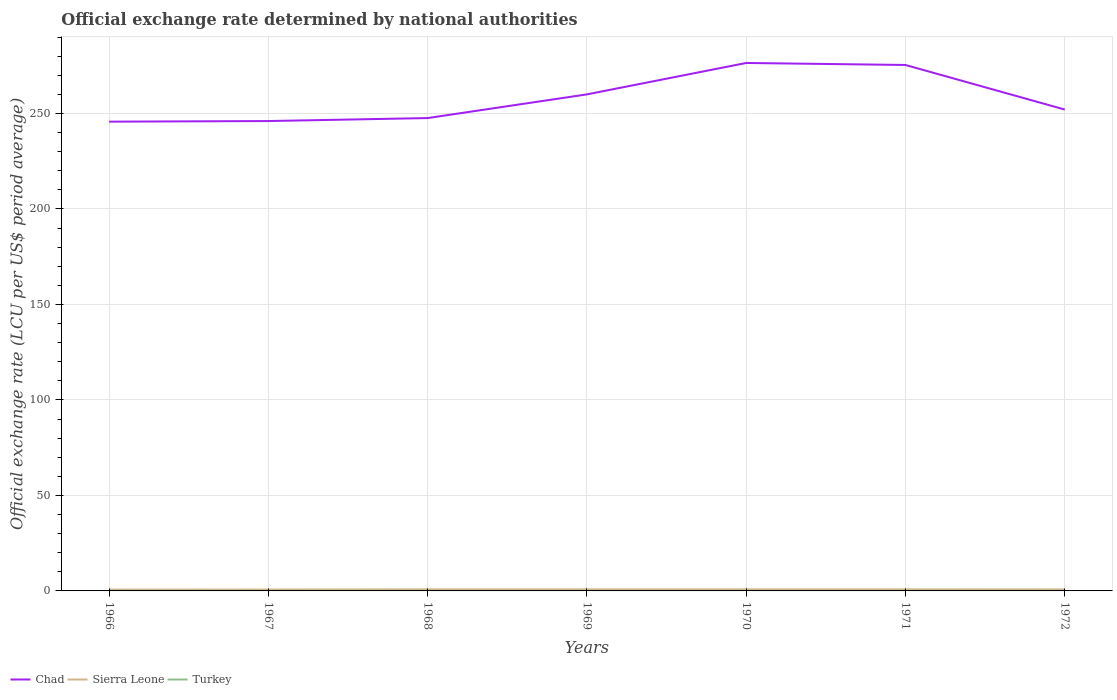Does the line corresponding to Sierra Leone intersect with the line corresponding to Chad?
Your response must be concise. No. Across all years, what is the maximum official exchange rate in Turkey?
Offer a very short reply. 9.039999999e-6. In which year was the official exchange rate in Sierra Leone maximum?
Keep it short and to the point. 1966. What is the total official exchange rate in Chad in the graph?
Offer a very short reply. -6.35. What is the difference between the highest and the second highest official exchange rate in Turkey?
Ensure brevity in your answer.  5.8266666680833e-6. How many lines are there?
Your answer should be very brief. 3. Does the graph contain any zero values?
Offer a terse response. No. Does the graph contain grids?
Provide a short and direct response. Yes. Where does the legend appear in the graph?
Your answer should be compact. Bottom left. How many legend labels are there?
Give a very brief answer. 3. How are the legend labels stacked?
Ensure brevity in your answer.  Horizontal. What is the title of the graph?
Make the answer very short. Official exchange rate determined by national authorities. Does "Hungary" appear as one of the legend labels in the graph?
Ensure brevity in your answer.  No. What is the label or title of the X-axis?
Your answer should be very brief. Years. What is the label or title of the Y-axis?
Make the answer very short. Official exchange rate (LCU per US$ period average). What is the Official exchange rate (LCU per US$ period average) of Chad in 1966?
Offer a terse response. 245.68. What is the Official exchange rate (LCU per US$ period average) of Sierra Leone in 1966?
Ensure brevity in your answer.  0.71. What is the Official exchange rate (LCU per US$ period average) in Turkey in 1966?
Make the answer very short. 9.039999999e-6. What is the Official exchange rate (LCU per US$ period average) in Chad in 1967?
Your response must be concise. 246. What is the Official exchange rate (LCU per US$ period average) in Sierra Leone in 1967?
Your answer should be very brief. 0.72. What is the Official exchange rate (LCU per US$ period average) of Turkey in 1967?
Provide a short and direct response. 9.039999999e-6. What is the Official exchange rate (LCU per US$ period average) of Chad in 1968?
Your answer should be compact. 247.56. What is the Official exchange rate (LCU per US$ period average) in Sierra Leone in 1968?
Your answer should be compact. 0.83. What is the Official exchange rate (LCU per US$ period average) in Turkey in 1968?
Give a very brief answer. 9.039999999e-6. What is the Official exchange rate (LCU per US$ period average) in Chad in 1969?
Your answer should be very brief. 259.96. What is the Official exchange rate (LCU per US$ period average) in Sierra Leone in 1969?
Ensure brevity in your answer.  0.83. What is the Official exchange rate (LCU per US$ period average) in Turkey in 1969?
Your answer should be very brief. 9.039999999e-6. What is the Official exchange rate (LCU per US$ period average) in Chad in 1970?
Offer a terse response. 276.4. What is the Official exchange rate (LCU per US$ period average) of Sierra Leone in 1970?
Keep it short and to the point. 0.83. What is the Official exchange rate (LCU per US$ period average) of Turkey in 1970?
Your answer should be very brief. 1.1328499999e-5. What is the Official exchange rate (LCU per US$ period average) in Chad in 1971?
Make the answer very short. 275.36. What is the Official exchange rate (LCU per US$ period average) of Sierra Leone in 1971?
Offer a very short reply. 0.83. What is the Official exchange rate (LCU per US$ period average) in Turkey in 1971?
Your response must be concise. 1.48666666670833e-5. What is the Official exchange rate (LCU per US$ period average) of Chad in 1972?
Give a very brief answer. 252.03. What is the Official exchange rate (LCU per US$ period average) in Sierra Leone in 1972?
Keep it short and to the point. 0.8. What is the Official exchange rate (LCU per US$ period average) of Turkey in 1972?
Your answer should be very brief. 1.415e-5. Across all years, what is the maximum Official exchange rate (LCU per US$ period average) of Chad?
Offer a terse response. 276.4. Across all years, what is the maximum Official exchange rate (LCU per US$ period average) of Sierra Leone?
Keep it short and to the point. 0.83. Across all years, what is the maximum Official exchange rate (LCU per US$ period average) in Turkey?
Your answer should be very brief. 1.48666666670833e-5. Across all years, what is the minimum Official exchange rate (LCU per US$ period average) of Chad?
Offer a terse response. 245.68. Across all years, what is the minimum Official exchange rate (LCU per US$ period average) in Sierra Leone?
Offer a very short reply. 0.71. Across all years, what is the minimum Official exchange rate (LCU per US$ period average) in Turkey?
Offer a terse response. 9.039999999e-6. What is the total Official exchange rate (LCU per US$ period average) of Chad in the graph?
Provide a succinct answer. 1802.99. What is the total Official exchange rate (LCU per US$ period average) in Sierra Leone in the graph?
Your answer should be very brief. 5.57. What is the difference between the Official exchange rate (LCU per US$ period average) in Chad in 1966 and that in 1967?
Ensure brevity in your answer.  -0.32. What is the difference between the Official exchange rate (LCU per US$ period average) in Sierra Leone in 1966 and that in 1967?
Your response must be concise. -0.01. What is the difference between the Official exchange rate (LCU per US$ period average) of Turkey in 1966 and that in 1967?
Your response must be concise. 0. What is the difference between the Official exchange rate (LCU per US$ period average) of Chad in 1966 and that in 1968?
Make the answer very short. -1.89. What is the difference between the Official exchange rate (LCU per US$ period average) in Sierra Leone in 1966 and that in 1968?
Your answer should be very brief. -0.12. What is the difference between the Official exchange rate (LCU per US$ period average) in Turkey in 1966 and that in 1968?
Your response must be concise. 0. What is the difference between the Official exchange rate (LCU per US$ period average) of Chad in 1966 and that in 1969?
Ensure brevity in your answer.  -14.28. What is the difference between the Official exchange rate (LCU per US$ period average) in Sierra Leone in 1966 and that in 1969?
Make the answer very short. -0.12. What is the difference between the Official exchange rate (LCU per US$ period average) in Chad in 1966 and that in 1970?
Give a very brief answer. -30.72. What is the difference between the Official exchange rate (LCU per US$ period average) of Sierra Leone in 1966 and that in 1970?
Your answer should be compact. -0.12. What is the difference between the Official exchange rate (LCU per US$ period average) of Chad in 1966 and that in 1971?
Give a very brief answer. -29.68. What is the difference between the Official exchange rate (LCU per US$ period average) in Sierra Leone in 1966 and that in 1971?
Offer a very short reply. -0.12. What is the difference between the Official exchange rate (LCU per US$ period average) in Turkey in 1966 and that in 1971?
Your answer should be compact. -0. What is the difference between the Official exchange rate (LCU per US$ period average) in Chad in 1966 and that in 1972?
Provide a short and direct response. -6.35. What is the difference between the Official exchange rate (LCU per US$ period average) in Sierra Leone in 1966 and that in 1972?
Your answer should be compact. -0.09. What is the difference between the Official exchange rate (LCU per US$ period average) in Turkey in 1966 and that in 1972?
Provide a succinct answer. -0. What is the difference between the Official exchange rate (LCU per US$ period average) of Chad in 1967 and that in 1968?
Provide a succinct answer. -1.56. What is the difference between the Official exchange rate (LCU per US$ period average) in Sierra Leone in 1967 and that in 1968?
Offer a terse response. -0.11. What is the difference between the Official exchange rate (LCU per US$ period average) of Chad in 1967 and that in 1969?
Offer a very short reply. -13.96. What is the difference between the Official exchange rate (LCU per US$ period average) of Sierra Leone in 1967 and that in 1969?
Offer a very short reply. -0.11. What is the difference between the Official exchange rate (LCU per US$ period average) of Chad in 1967 and that in 1970?
Make the answer very short. -30.4. What is the difference between the Official exchange rate (LCU per US$ period average) in Sierra Leone in 1967 and that in 1970?
Your response must be concise. -0.11. What is the difference between the Official exchange rate (LCU per US$ period average) in Turkey in 1967 and that in 1970?
Provide a succinct answer. -0. What is the difference between the Official exchange rate (LCU per US$ period average) in Chad in 1967 and that in 1971?
Provide a succinct answer. -29.36. What is the difference between the Official exchange rate (LCU per US$ period average) of Sierra Leone in 1967 and that in 1971?
Your answer should be compact. -0.11. What is the difference between the Official exchange rate (LCU per US$ period average) of Chad in 1967 and that in 1972?
Ensure brevity in your answer.  -6.03. What is the difference between the Official exchange rate (LCU per US$ period average) in Sierra Leone in 1967 and that in 1972?
Make the answer very short. -0.08. What is the difference between the Official exchange rate (LCU per US$ period average) in Chad in 1968 and that in 1969?
Give a very brief answer. -12.4. What is the difference between the Official exchange rate (LCU per US$ period average) in Sierra Leone in 1968 and that in 1969?
Provide a short and direct response. 0. What is the difference between the Official exchange rate (LCU per US$ period average) of Turkey in 1968 and that in 1969?
Ensure brevity in your answer.  0. What is the difference between the Official exchange rate (LCU per US$ period average) of Chad in 1968 and that in 1970?
Your answer should be very brief. -28.84. What is the difference between the Official exchange rate (LCU per US$ period average) of Sierra Leone in 1968 and that in 1970?
Offer a terse response. 0. What is the difference between the Official exchange rate (LCU per US$ period average) of Chad in 1968 and that in 1971?
Offer a terse response. -27.79. What is the difference between the Official exchange rate (LCU per US$ period average) in Sierra Leone in 1968 and that in 1971?
Your answer should be compact. 0. What is the difference between the Official exchange rate (LCU per US$ period average) of Chad in 1968 and that in 1972?
Your response must be concise. -4.46. What is the difference between the Official exchange rate (LCU per US$ period average) of Sierra Leone in 1968 and that in 1972?
Provide a short and direct response. 0.03. What is the difference between the Official exchange rate (LCU per US$ period average) in Turkey in 1968 and that in 1972?
Offer a very short reply. -0. What is the difference between the Official exchange rate (LCU per US$ period average) of Chad in 1969 and that in 1970?
Your answer should be compact. -16.44. What is the difference between the Official exchange rate (LCU per US$ period average) of Sierra Leone in 1969 and that in 1970?
Your answer should be compact. 0. What is the difference between the Official exchange rate (LCU per US$ period average) of Chad in 1969 and that in 1971?
Provide a short and direct response. -15.4. What is the difference between the Official exchange rate (LCU per US$ period average) of Sierra Leone in 1969 and that in 1971?
Offer a terse response. 0. What is the difference between the Official exchange rate (LCU per US$ period average) in Chad in 1969 and that in 1972?
Provide a succinct answer. 7.93. What is the difference between the Official exchange rate (LCU per US$ period average) of Sierra Leone in 1969 and that in 1972?
Give a very brief answer. 0.03. What is the difference between the Official exchange rate (LCU per US$ period average) in Chad in 1970 and that in 1971?
Offer a terse response. 1.05. What is the difference between the Official exchange rate (LCU per US$ period average) in Sierra Leone in 1970 and that in 1971?
Make the answer very short. 0. What is the difference between the Official exchange rate (LCU per US$ period average) of Turkey in 1970 and that in 1971?
Offer a terse response. -0. What is the difference between the Official exchange rate (LCU per US$ period average) of Chad in 1970 and that in 1972?
Your answer should be very brief. 24.38. What is the difference between the Official exchange rate (LCU per US$ period average) in Sierra Leone in 1970 and that in 1972?
Make the answer very short. 0.03. What is the difference between the Official exchange rate (LCU per US$ period average) of Chad in 1971 and that in 1972?
Provide a succinct answer. 23.33. What is the difference between the Official exchange rate (LCU per US$ period average) of Sierra Leone in 1971 and that in 1972?
Your answer should be very brief. 0.03. What is the difference between the Official exchange rate (LCU per US$ period average) in Turkey in 1971 and that in 1972?
Your answer should be compact. 0. What is the difference between the Official exchange rate (LCU per US$ period average) in Chad in 1966 and the Official exchange rate (LCU per US$ period average) in Sierra Leone in 1967?
Keep it short and to the point. 244.95. What is the difference between the Official exchange rate (LCU per US$ period average) of Chad in 1966 and the Official exchange rate (LCU per US$ period average) of Turkey in 1967?
Keep it short and to the point. 245.68. What is the difference between the Official exchange rate (LCU per US$ period average) of Sierra Leone in 1966 and the Official exchange rate (LCU per US$ period average) of Turkey in 1967?
Give a very brief answer. 0.71. What is the difference between the Official exchange rate (LCU per US$ period average) in Chad in 1966 and the Official exchange rate (LCU per US$ period average) in Sierra Leone in 1968?
Your answer should be very brief. 244.85. What is the difference between the Official exchange rate (LCU per US$ period average) of Chad in 1966 and the Official exchange rate (LCU per US$ period average) of Turkey in 1968?
Make the answer very short. 245.68. What is the difference between the Official exchange rate (LCU per US$ period average) in Sierra Leone in 1966 and the Official exchange rate (LCU per US$ period average) in Turkey in 1968?
Ensure brevity in your answer.  0.71. What is the difference between the Official exchange rate (LCU per US$ period average) of Chad in 1966 and the Official exchange rate (LCU per US$ period average) of Sierra Leone in 1969?
Offer a very short reply. 244.85. What is the difference between the Official exchange rate (LCU per US$ period average) in Chad in 1966 and the Official exchange rate (LCU per US$ period average) in Turkey in 1969?
Provide a succinct answer. 245.68. What is the difference between the Official exchange rate (LCU per US$ period average) in Sierra Leone in 1966 and the Official exchange rate (LCU per US$ period average) in Turkey in 1969?
Give a very brief answer. 0.71. What is the difference between the Official exchange rate (LCU per US$ period average) of Chad in 1966 and the Official exchange rate (LCU per US$ period average) of Sierra Leone in 1970?
Make the answer very short. 244.85. What is the difference between the Official exchange rate (LCU per US$ period average) of Chad in 1966 and the Official exchange rate (LCU per US$ period average) of Turkey in 1970?
Provide a succinct answer. 245.68. What is the difference between the Official exchange rate (LCU per US$ period average) of Chad in 1966 and the Official exchange rate (LCU per US$ period average) of Sierra Leone in 1971?
Make the answer very short. 244.85. What is the difference between the Official exchange rate (LCU per US$ period average) of Chad in 1966 and the Official exchange rate (LCU per US$ period average) of Turkey in 1971?
Ensure brevity in your answer.  245.68. What is the difference between the Official exchange rate (LCU per US$ period average) of Chad in 1966 and the Official exchange rate (LCU per US$ period average) of Sierra Leone in 1972?
Your response must be concise. 244.88. What is the difference between the Official exchange rate (LCU per US$ period average) in Chad in 1966 and the Official exchange rate (LCU per US$ period average) in Turkey in 1972?
Your answer should be compact. 245.68. What is the difference between the Official exchange rate (LCU per US$ period average) of Sierra Leone in 1966 and the Official exchange rate (LCU per US$ period average) of Turkey in 1972?
Your response must be concise. 0.71. What is the difference between the Official exchange rate (LCU per US$ period average) of Chad in 1967 and the Official exchange rate (LCU per US$ period average) of Sierra Leone in 1968?
Ensure brevity in your answer.  245.17. What is the difference between the Official exchange rate (LCU per US$ period average) of Chad in 1967 and the Official exchange rate (LCU per US$ period average) of Turkey in 1968?
Provide a short and direct response. 246. What is the difference between the Official exchange rate (LCU per US$ period average) of Sierra Leone in 1967 and the Official exchange rate (LCU per US$ period average) of Turkey in 1968?
Give a very brief answer. 0.72. What is the difference between the Official exchange rate (LCU per US$ period average) of Chad in 1967 and the Official exchange rate (LCU per US$ period average) of Sierra Leone in 1969?
Provide a short and direct response. 245.17. What is the difference between the Official exchange rate (LCU per US$ period average) of Chad in 1967 and the Official exchange rate (LCU per US$ period average) of Turkey in 1969?
Offer a terse response. 246. What is the difference between the Official exchange rate (LCU per US$ period average) in Sierra Leone in 1967 and the Official exchange rate (LCU per US$ period average) in Turkey in 1969?
Ensure brevity in your answer.  0.72. What is the difference between the Official exchange rate (LCU per US$ period average) in Chad in 1967 and the Official exchange rate (LCU per US$ period average) in Sierra Leone in 1970?
Make the answer very short. 245.17. What is the difference between the Official exchange rate (LCU per US$ period average) in Chad in 1967 and the Official exchange rate (LCU per US$ period average) in Turkey in 1970?
Your response must be concise. 246. What is the difference between the Official exchange rate (LCU per US$ period average) in Sierra Leone in 1967 and the Official exchange rate (LCU per US$ period average) in Turkey in 1970?
Keep it short and to the point. 0.72. What is the difference between the Official exchange rate (LCU per US$ period average) in Chad in 1967 and the Official exchange rate (LCU per US$ period average) in Sierra Leone in 1971?
Provide a short and direct response. 245.17. What is the difference between the Official exchange rate (LCU per US$ period average) of Chad in 1967 and the Official exchange rate (LCU per US$ period average) of Turkey in 1971?
Make the answer very short. 246. What is the difference between the Official exchange rate (LCU per US$ period average) of Sierra Leone in 1967 and the Official exchange rate (LCU per US$ period average) of Turkey in 1971?
Your answer should be compact. 0.72. What is the difference between the Official exchange rate (LCU per US$ period average) of Chad in 1967 and the Official exchange rate (LCU per US$ period average) of Sierra Leone in 1972?
Provide a succinct answer. 245.2. What is the difference between the Official exchange rate (LCU per US$ period average) in Chad in 1967 and the Official exchange rate (LCU per US$ period average) in Turkey in 1972?
Offer a very short reply. 246. What is the difference between the Official exchange rate (LCU per US$ period average) in Sierra Leone in 1967 and the Official exchange rate (LCU per US$ period average) in Turkey in 1972?
Make the answer very short. 0.72. What is the difference between the Official exchange rate (LCU per US$ period average) in Chad in 1968 and the Official exchange rate (LCU per US$ period average) in Sierra Leone in 1969?
Make the answer very short. 246.73. What is the difference between the Official exchange rate (LCU per US$ period average) of Chad in 1968 and the Official exchange rate (LCU per US$ period average) of Turkey in 1969?
Give a very brief answer. 247.56. What is the difference between the Official exchange rate (LCU per US$ period average) in Chad in 1968 and the Official exchange rate (LCU per US$ period average) in Sierra Leone in 1970?
Ensure brevity in your answer.  246.73. What is the difference between the Official exchange rate (LCU per US$ period average) in Chad in 1968 and the Official exchange rate (LCU per US$ period average) in Turkey in 1970?
Make the answer very short. 247.56. What is the difference between the Official exchange rate (LCU per US$ period average) of Chad in 1968 and the Official exchange rate (LCU per US$ period average) of Sierra Leone in 1971?
Your answer should be compact. 246.73. What is the difference between the Official exchange rate (LCU per US$ period average) of Chad in 1968 and the Official exchange rate (LCU per US$ period average) of Turkey in 1971?
Offer a terse response. 247.56. What is the difference between the Official exchange rate (LCU per US$ period average) in Sierra Leone in 1968 and the Official exchange rate (LCU per US$ period average) in Turkey in 1971?
Offer a very short reply. 0.83. What is the difference between the Official exchange rate (LCU per US$ period average) in Chad in 1968 and the Official exchange rate (LCU per US$ period average) in Sierra Leone in 1972?
Make the answer very short. 246.76. What is the difference between the Official exchange rate (LCU per US$ period average) of Chad in 1968 and the Official exchange rate (LCU per US$ period average) of Turkey in 1972?
Offer a terse response. 247.56. What is the difference between the Official exchange rate (LCU per US$ period average) in Chad in 1969 and the Official exchange rate (LCU per US$ period average) in Sierra Leone in 1970?
Offer a very short reply. 259.13. What is the difference between the Official exchange rate (LCU per US$ period average) of Chad in 1969 and the Official exchange rate (LCU per US$ period average) of Turkey in 1970?
Your answer should be compact. 259.96. What is the difference between the Official exchange rate (LCU per US$ period average) of Sierra Leone in 1969 and the Official exchange rate (LCU per US$ period average) of Turkey in 1970?
Your answer should be compact. 0.83. What is the difference between the Official exchange rate (LCU per US$ period average) of Chad in 1969 and the Official exchange rate (LCU per US$ period average) of Sierra Leone in 1971?
Your answer should be compact. 259.13. What is the difference between the Official exchange rate (LCU per US$ period average) in Chad in 1969 and the Official exchange rate (LCU per US$ period average) in Turkey in 1971?
Provide a short and direct response. 259.96. What is the difference between the Official exchange rate (LCU per US$ period average) in Sierra Leone in 1969 and the Official exchange rate (LCU per US$ period average) in Turkey in 1971?
Provide a short and direct response. 0.83. What is the difference between the Official exchange rate (LCU per US$ period average) in Chad in 1969 and the Official exchange rate (LCU per US$ period average) in Sierra Leone in 1972?
Your response must be concise. 259.16. What is the difference between the Official exchange rate (LCU per US$ period average) of Chad in 1969 and the Official exchange rate (LCU per US$ period average) of Turkey in 1972?
Give a very brief answer. 259.96. What is the difference between the Official exchange rate (LCU per US$ period average) of Sierra Leone in 1969 and the Official exchange rate (LCU per US$ period average) of Turkey in 1972?
Ensure brevity in your answer.  0.83. What is the difference between the Official exchange rate (LCU per US$ period average) in Chad in 1970 and the Official exchange rate (LCU per US$ period average) in Sierra Leone in 1971?
Your answer should be very brief. 275.57. What is the difference between the Official exchange rate (LCU per US$ period average) of Chad in 1970 and the Official exchange rate (LCU per US$ period average) of Turkey in 1971?
Provide a short and direct response. 276.4. What is the difference between the Official exchange rate (LCU per US$ period average) in Sierra Leone in 1970 and the Official exchange rate (LCU per US$ period average) in Turkey in 1971?
Offer a terse response. 0.83. What is the difference between the Official exchange rate (LCU per US$ period average) in Chad in 1970 and the Official exchange rate (LCU per US$ period average) in Sierra Leone in 1972?
Offer a very short reply. 275.6. What is the difference between the Official exchange rate (LCU per US$ period average) in Chad in 1970 and the Official exchange rate (LCU per US$ period average) in Turkey in 1972?
Make the answer very short. 276.4. What is the difference between the Official exchange rate (LCU per US$ period average) in Sierra Leone in 1970 and the Official exchange rate (LCU per US$ period average) in Turkey in 1972?
Ensure brevity in your answer.  0.83. What is the difference between the Official exchange rate (LCU per US$ period average) of Chad in 1971 and the Official exchange rate (LCU per US$ period average) of Sierra Leone in 1972?
Make the answer very short. 274.56. What is the difference between the Official exchange rate (LCU per US$ period average) of Chad in 1971 and the Official exchange rate (LCU per US$ period average) of Turkey in 1972?
Make the answer very short. 275.36. What is the difference between the Official exchange rate (LCU per US$ period average) in Sierra Leone in 1971 and the Official exchange rate (LCU per US$ period average) in Turkey in 1972?
Make the answer very short. 0.83. What is the average Official exchange rate (LCU per US$ period average) in Chad per year?
Offer a terse response. 257.57. What is the average Official exchange rate (LCU per US$ period average) of Sierra Leone per year?
Offer a very short reply. 0.8. In the year 1966, what is the difference between the Official exchange rate (LCU per US$ period average) in Chad and Official exchange rate (LCU per US$ period average) in Sierra Leone?
Offer a very short reply. 244.96. In the year 1966, what is the difference between the Official exchange rate (LCU per US$ period average) of Chad and Official exchange rate (LCU per US$ period average) of Turkey?
Keep it short and to the point. 245.68. In the year 1967, what is the difference between the Official exchange rate (LCU per US$ period average) of Chad and Official exchange rate (LCU per US$ period average) of Sierra Leone?
Your answer should be very brief. 245.28. In the year 1967, what is the difference between the Official exchange rate (LCU per US$ period average) of Chad and Official exchange rate (LCU per US$ period average) of Turkey?
Provide a succinct answer. 246. In the year 1967, what is the difference between the Official exchange rate (LCU per US$ period average) of Sierra Leone and Official exchange rate (LCU per US$ period average) of Turkey?
Offer a terse response. 0.72. In the year 1968, what is the difference between the Official exchange rate (LCU per US$ period average) in Chad and Official exchange rate (LCU per US$ period average) in Sierra Leone?
Keep it short and to the point. 246.73. In the year 1968, what is the difference between the Official exchange rate (LCU per US$ period average) in Chad and Official exchange rate (LCU per US$ period average) in Turkey?
Provide a short and direct response. 247.56. In the year 1968, what is the difference between the Official exchange rate (LCU per US$ period average) in Sierra Leone and Official exchange rate (LCU per US$ period average) in Turkey?
Your answer should be compact. 0.83. In the year 1969, what is the difference between the Official exchange rate (LCU per US$ period average) of Chad and Official exchange rate (LCU per US$ period average) of Sierra Leone?
Your response must be concise. 259.13. In the year 1969, what is the difference between the Official exchange rate (LCU per US$ period average) in Chad and Official exchange rate (LCU per US$ period average) in Turkey?
Provide a succinct answer. 259.96. In the year 1970, what is the difference between the Official exchange rate (LCU per US$ period average) of Chad and Official exchange rate (LCU per US$ period average) of Sierra Leone?
Provide a short and direct response. 275.57. In the year 1970, what is the difference between the Official exchange rate (LCU per US$ period average) in Chad and Official exchange rate (LCU per US$ period average) in Turkey?
Your answer should be compact. 276.4. In the year 1970, what is the difference between the Official exchange rate (LCU per US$ period average) in Sierra Leone and Official exchange rate (LCU per US$ period average) in Turkey?
Provide a short and direct response. 0.83. In the year 1971, what is the difference between the Official exchange rate (LCU per US$ period average) in Chad and Official exchange rate (LCU per US$ period average) in Sierra Leone?
Keep it short and to the point. 274.53. In the year 1971, what is the difference between the Official exchange rate (LCU per US$ period average) of Chad and Official exchange rate (LCU per US$ period average) of Turkey?
Your answer should be compact. 275.36. In the year 1971, what is the difference between the Official exchange rate (LCU per US$ period average) in Sierra Leone and Official exchange rate (LCU per US$ period average) in Turkey?
Your response must be concise. 0.83. In the year 1972, what is the difference between the Official exchange rate (LCU per US$ period average) in Chad and Official exchange rate (LCU per US$ period average) in Sierra Leone?
Provide a succinct answer. 251.23. In the year 1972, what is the difference between the Official exchange rate (LCU per US$ period average) in Chad and Official exchange rate (LCU per US$ period average) in Turkey?
Your answer should be compact. 252.03. In the year 1972, what is the difference between the Official exchange rate (LCU per US$ period average) in Sierra Leone and Official exchange rate (LCU per US$ period average) in Turkey?
Provide a short and direct response. 0.8. What is the ratio of the Official exchange rate (LCU per US$ period average) in Chad in 1966 to that in 1967?
Ensure brevity in your answer.  1. What is the ratio of the Official exchange rate (LCU per US$ period average) of Sierra Leone in 1966 to that in 1967?
Offer a terse response. 0.99. What is the ratio of the Official exchange rate (LCU per US$ period average) in Turkey in 1966 to that in 1967?
Offer a very short reply. 1. What is the ratio of the Official exchange rate (LCU per US$ period average) of Turkey in 1966 to that in 1968?
Ensure brevity in your answer.  1. What is the ratio of the Official exchange rate (LCU per US$ period average) of Chad in 1966 to that in 1969?
Provide a succinct answer. 0.95. What is the ratio of the Official exchange rate (LCU per US$ period average) of Sierra Leone in 1966 to that in 1969?
Your response must be concise. 0.86. What is the ratio of the Official exchange rate (LCU per US$ period average) of Chad in 1966 to that in 1970?
Ensure brevity in your answer.  0.89. What is the ratio of the Official exchange rate (LCU per US$ period average) in Turkey in 1966 to that in 1970?
Keep it short and to the point. 0.8. What is the ratio of the Official exchange rate (LCU per US$ period average) in Chad in 1966 to that in 1971?
Your answer should be compact. 0.89. What is the ratio of the Official exchange rate (LCU per US$ period average) of Sierra Leone in 1966 to that in 1971?
Your answer should be compact. 0.86. What is the ratio of the Official exchange rate (LCU per US$ period average) of Turkey in 1966 to that in 1971?
Make the answer very short. 0.61. What is the ratio of the Official exchange rate (LCU per US$ period average) of Chad in 1966 to that in 1972?
Provide a succinct answer. 0.97. What is the ratio of the Official exchange rate (LCU per US$ period average) of Sierra Leone in 1966 to that in 1972?
Offer a very short reply. 0.89. What is the ratio of the Official exchange rate (LCU per US$ period average) of Turkey in 1966 to that in 1972?
Provide a short and direct response. 0.64. What is the ratio of the Official exchange rate (LCU per US$ period average) of Sierra Leone in 1967 to that in 1968?
Provide a short and direct response. 0.87. What is the ratio of the Official exchange rate (LCU per US$ period average) in Chad in 1967 to that in 1969?
Provide a short and direct response. 0.95. What is the ratio of the Official exchange rate (LCU per US$ period average) in Sierra Leone in 1967 to that in 1969?
Your answer should be very brief. 0.87. What is the ratio of the Official exchange rate (LCU per US$ period average) in Chad in 1967 to that in 1970?
Give a very brief answer. 0.89. What is the ratio of the Official exchange rate (LCU per US$ period average) in Sierra Leone in 1967 to that in 1970?
Keep it short and to the point. 0.87. What is the ratio of the Official exchange rate (LCU per US$ period average) of Turkey in 1967 to that in 1970?
Provide a short and direct response. 0.8. What is the ratio of the Official exchange rate (LCU per US$ period average) in Chad in 1967 to that in 1971?
Your answer should be very brief. 0.89. What is the ratio of the Official exchange rate (LCU per US$ period average) in Sierra Leone in 1967 to that in 1971?
Ensure brevity in your answer.  0.87. What is the ratio of the Official exchange rate (LCU per US$ period average) of Turkey in 1967 to that in 1971?
Provide a succinct answer. 0.61. What is the ratio of the Official exchange rate (LCU per US$ period average) of Chad in 1967 to that in 1972?
Your response must be concise. 0.98. What is the ratio of the Official exchange rate (LCU per US$ period average) in Sierra Leone in 1967 to that in 1972?
Provide a short and direct response. 0.9. What is the ratio of the Official exchange rate (LCU per US$ period average) of Turkey in 1967 to that in 1972?
Offer a very short reply. 0.64. What is the ratio of the Official exchange rate (LCU per US$ period average) of Chad in 1968 to that in 1969?
Your answer should be very brief. 0.95. What is the ratio of the Official exchange rate (LCU per US$ period average) of Sierra Leone in 1968 to that in 1969?
Your answer should be very brief. 1. What is the ratio of the Official exchange rate (LCU per US$ period average) in Chad in 1968 to that in 1970?
Give a very brief answer. 0.9. What is the ratio of the Official exchange rate (LCU per US$ period average) of Turkey in 1968 to that in 1970?
Ensure brevity in your answer.  0.8. What is the ratio of the Official exchange rate (LCU per US$ period average) of Chad in 1968 to that in 1971?
Provide a succinct answer. 0.9. What is the ratio of the Official exchange rate (LCU per US$ period average) of Sierra Leone in 1968 to that in 1971?
Make the answer very short. 1. What is the ratio of the Official exchange rate (LCU per US$ period average) in Turkey in 1968 to that in 1971?
Your answer should be compact. 0.61. What is the ratio of the Official exchange rate (LCU per US$ period average) in Chad in 1968 to that in 1972?
Keep it short and to the point. 0.98. What is the ratio of the Official exchange rate (LCU per US$ period average) in Sierra Leone in 1968 to that in 1972?
Provide a short and direct response. 1.04. What is the ratio of the Official exchange rate (LCU per US$ period average) of Turkey in 1968 to that in 1972?
Keep it short and to the point. 0.64. What is the ratio of the Official exchange rate (LCU per US$ period average) of Chad in 1969 to that in 1970?
Make the answer very short. 0.94. What is the ratio of the Official exchange rate (LCU per US$ period average) of Turkey in 1969 to that in 1970?
Offer a terse response. 0.8. What is the ratio of the Official exchange rate (LCU per US$ period average) in Chad in 1969 to that in 1971?
Offer a terse response. 0.94. What is the ratio of the Official exchange rate (LCU per US$ period average) of Turkey in 1969 to that in 1971?
Ensure brevity in your answer.  0.61. What is the ratio of the Official exchange rate (LCU per US$ period average) in Chad in 1969 to that in 1972?
Offer a very short reply. 1.03. What is the ratio of the Official exchange rate (LCU per US$ period average) of Sierra Leone in 1969 to that in 1972?
Your answer should be compact. 1.04. What is the ratio of the Official exchange rate (LCU per US$ period average) of Turkey in 1969 to that in 1972?
Provide a succinct answer. 0.64. What is the ratio of the Official exchange rate (LCU per US$ period average) in Turkey in 1970 to that in 1971?
Make the answer very short. 0.76. What is the ratio of the Official exchange rate (LCU per US$ period average) in Chad in 1970 to that in 1972?
Your answer should be compact. 1.1. What is the ratio of the Official exchange rate (LCU per US$ period average) in Sierra Leone in 1970 to that in 1972?
Make the answer very short. 1.04. What is the ratio of the Official exchange rate (LCU per US$ period average) in Turkey in 1970 to that in 1972?
Make the answer very short. 0.8. What is the ratio of the Official exchange rate (LCU per US$ period average) of Chad in 1971 to that in 1972?
Offer a very short reply. 1.09. What is the ratio of the Official exchange rate (LCU per US$ period average) of Sierra Leone in 1971 to that in 1972?
Offer a terse response. 1.04. What is the ratio of the Official exchange rate (LCU per US$ period average) in Turkey in 1971 to that in 1972?
Your answer should be compact. 1.05. What is the difference between the highest and the second highest Official exchange rate (LCU per US$ period average) of Chad?
Offer a terse response. 1.05. What is the difference between the highest and the second highest Official exchange rate (LCU per US$ period average) of Turkey?
Your answer should be compact. 0. What is the difference between the highest and the lowest Official exchange rate (LCU per US$ period average) in Chad?
Your answer should be very brief. 30.72. What is the difference between the highest and the lowest Official exchange rate (LCU per US$ period average) in Sierra Leone?
Offer a terse response. 0.12. 